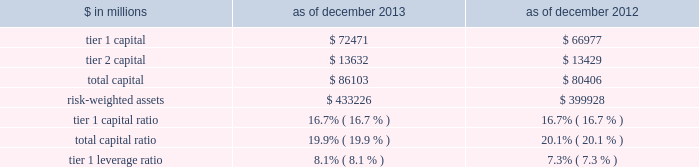Notes to consolidated financial statements the table below presents information regarding group inc . 2019s regulatory capital ratios and tier 1 leverage ratio under basel i , as implemented by the federal reserve board .
The information as of december 2013 reflects the revised market risk regulatory capital requirements .
These changes resulted in increased regulatory capital requirements for market risk .
The information as of december 2012 is prior to the implementation of these revised market risk regulatory capital requirements. .
Revised capital framework the u.s .
Federal bank regulatory agencies ( agencies ) have approved revised risk-based capital and leverage ratio regulations establishing a new comprehensive capital framework for u.s .
Banking organizations ( revised capital framework ) .
These regulations are largely based on the basel committee 2019s december 2010 final capital framework for strengthening international capital standards ( basel iii ) and also implement certain provisions of the dodd-frank act .
Under the revised capital framework , group inc .
Is an 201cadvanced approach 201d banking organization .
Below are the aspects of the rules that are most relevant to the firm , as an advanced approach banking organization .
Definition of capital and capital ratios .
The revised capital framework introduced changes to the definition of regulatory capital , which , subject to transitional provisions , became effective across the firm 2019s regulatory capital and leverage ratios on january 1 , 2014 .
These changes include the introduction of a new capital measure called common equity tier 1 ( cet1 ) , and the related regulatory capital ratio of cet1 to rwas ( cet1 ratio ) .
In addition , the definition of tier 1 capital has been narrowed to include only cet1 and instruments such as perpetual non- cumulative preferred stock , which meet certain criteria .
Certain aspects of the revised requirements phase in over time .
These include increases in the minimum capital ratio requirements and the introduction of new capital buffers and certain deductions from regulatory capital ( such as investments in nonconsolidated financial institutions ) .
In addition , junior subordinated debt issued to trusts is being phased out of regulatory capital .
The minimum cet1 ratio is 4.0% ( 4.0 % ) as of january 1 , 2014 and will increase to 4.5% ( 4.5 % ) on january 1 , 2015 .
The minimum tier 1 capital ratio increased from 4.0% ( 4.0 % ) to 5.5% ( 5.5 % ) on january 1 , 2014 and will increase to 6.0% ( 6.0 % ) beginning january 1 , 2015 .
The minimum total capital ratio remains unchanged at 8.0% ( 8.0 % ) .
These minimum ratios will be supplemented by a new capital conservation buffer that phases in , beginning january 1 , 2016 , in increments of 0.625% ( 0.625 % ) per year until it reaches 2.5% ( 2.5 % ) on january 1 , 2019 .
The revised capital framework also introduces a new counter-cyclical capital buffer , to be imposed in the event that national supervisors deem it necessary in order to counteract excessive credit growth .
Risk-weighted assets .
In february 2014 , the federal reserve board informed us that we have completed a satisfactory 201cparallel run , 201d as required of advanced approach banking organizations under the revised capital framework , and therefore changes to rwas will take effect beginning with the second quarter of 2014 .
Accordingly , the calculation of rwas in future quarters will be based on the following methodologies : 2030 during the first quarter of 2014 2014 the basel i risk-based capital framework adjusted for certain items related to existing capital deductions and the phase-in of new capital deductions ( basel i adjusted ) ; 2030 during the remaining quarters of 2014 2014 the higher of rwas computed under the basel iii advanced approach or the basel i adjusted calculation ; and 2030 beginning in the first quarter of 2015 2014 the higher of rwas computed under the basel iii advanced or standardized approach .
Goldman sachs 2013 annual report 191 .
In millions , for 2013 and 2012 , what was average tier 1 capital?\\n? 
Computations: table_average(tier 1 capital, none)
Answer: 69724.0. 